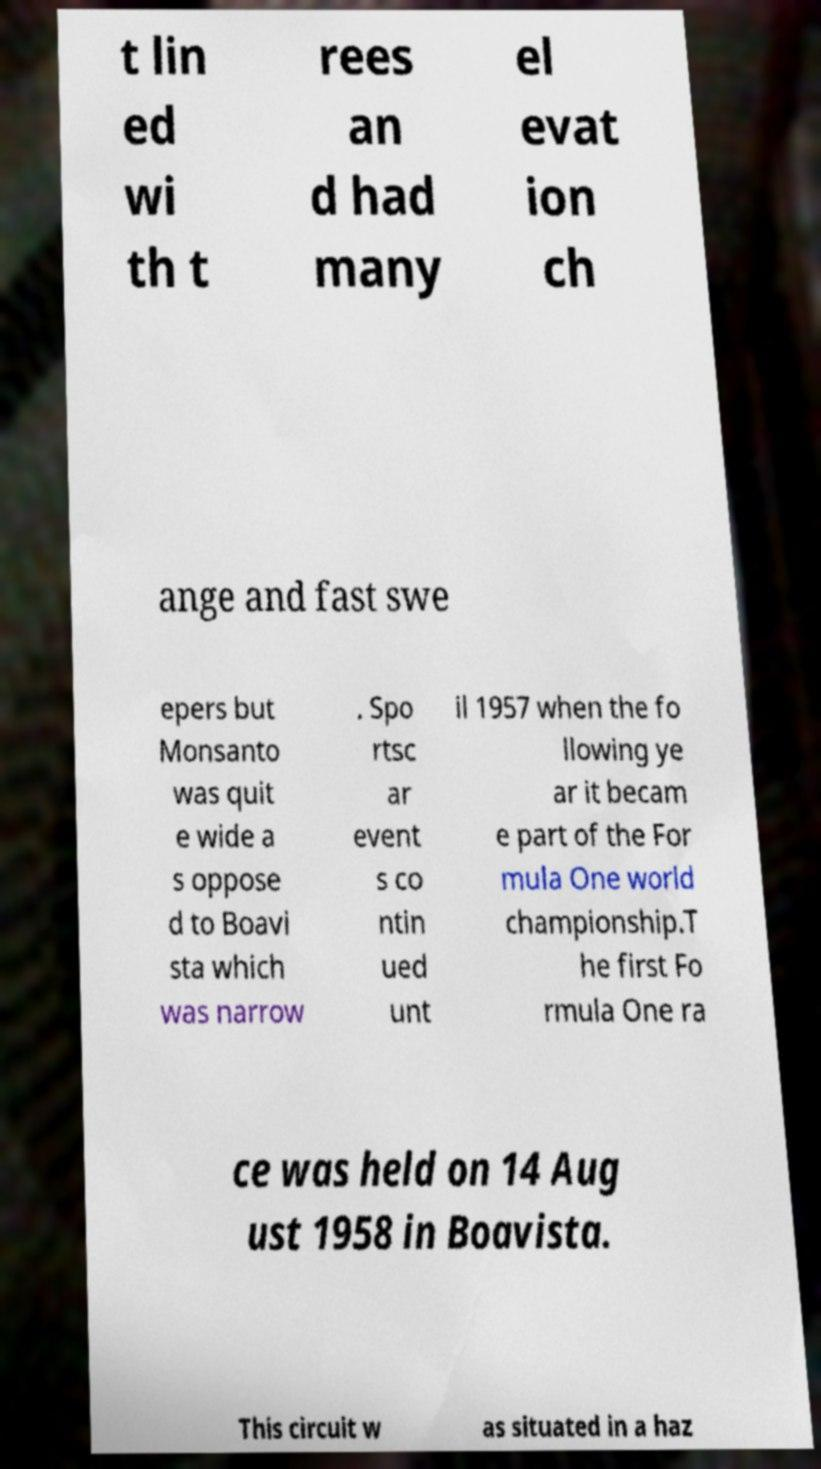Could you extract and type out the text from this image? t lin ed wi th t rees an d had many el evat ion ch ange and fast swe epers but Monsanto was quit e wide a s oppose d to Boavi sta which was narrow . Spo rtsc ar event s co ntin ued unt il 1957 when the fo llowing ye ar it becam e part of the For mula One world championship.T he first Fo rmula One ra ce was held on 14 Aug ust 1958 in Boavista. This circuit w as situated in a haz 